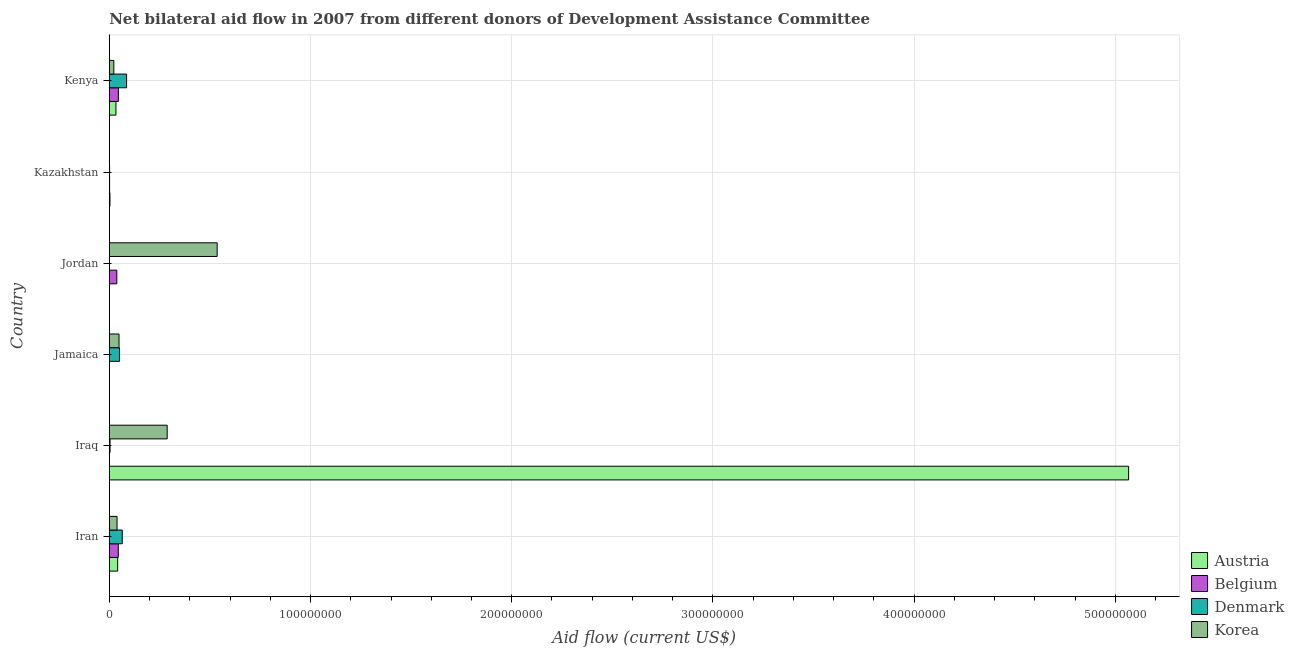How many groups of bars are there?
Ensure brevity in your answer.  6. Are the number of bars per tick equal to the number of legend labels?
Keep it short and to the point. No. Are the number of bars on each tick of the Y-axis equal?
Your response must be concise. No. What is the label of the 4th group of bars from the top?
Offer a very short reply. Jamaica. In how many cases, is the number of bars for a given country not equal to the number of legend labels?
Keep it short and to the point. 2. What is the amount of aid given by austria in Iran?
Your response must be concise. 4.17e+06. Across all countries, what is the maximum amount of aid given by denmark?
Your answer should be compact. 8.61e+06. Across all countries, what is the minimum amount of aid given by denmark?
Keep it short and to the point. 0. In which country was the amount of aid given by belgium maximum?
Give a very brief answer. Kenya. What is the total amount of aid given by denmark in the graph?
Provide a succinct answer. 2.07e+07. What is the difference between the amount of aid given by belgium in Jamaica and that in Kazakhstan?
Your response must be concise. -1.00e+05. What is the difference between the amount of aid given by denmark in Iran and the amount of aid given by korea in Jordan?
Give a very brief answer. -4.72e+07. What is the average amount of aid given by korea per country?
Your answer should be very brief. 1.56e+07. What is the difference between the amount of aid given by austria and amount of aid given by denmark in Kenya?
Make the answer very short. -5.30e+06. What is the ratio of the amount of aid given by korea in Kazakhstan to that in Kenya?
Offer a terse response. 0.04. What is the difference between the highest and the second highest amount of aid given by denmark?
Provide a succinct answer. 2.16e+06. What is the difference between the highest and the lowest amount of aid given by korea?
Provide a short and direct response. 5.35e+07. Is it the case that in every country, the sum of the amount of aid given by korea and amount of aid given by denmark is greater than the sum of amount of aid given by austria and amount of aid given by belgium?
Offer a very short reply. No. How many bars are there?
Your response must be concise. 22. Are all the bars in the graph horizontal?
Offer a terse response. Yes. What is the difference between two consecutive major ticks on the X-axis?
Your answer should be compact. 1.00e+08. Are the values on the major ticks of X-axis written in scientific E-notation?
Your response must be concise. No. Does the graph contain any zero values?
Make the answer very short. Yes. Does the graph contain grids?
Provide a short and direct response. Yes. How many legend labels are there?
Your answer should be very brief. 4. What is the title of the graph?
Give a very brief answer. Net bilateral aid flow in 2007 from different donors of Development Assistance Committee. What is the label or title of the Y-axis?
Give a very brief answer. Country. What is the Aid flow (current US$) of Austria in Iran?
Keep it short and to the point. 4.17e+06. What is the Aid flow (current US$) of Belgium in Iran?
Keep it short and to the point. 4.48e+06. What is the Aid flow (current US$) of Denmark in Iran?
Keep it short and to the point. 6.45e+06. What is the Aid flow (current US$) of Korea in Iran?
Your response must be concise. 3.86e+06. What is the Aid flow (current US$) in Austria in Iraq?
Give a very brief answer. 5.07e+08. What is the Aid flow (current US$) of Belgium in Iraq?
Your answer should be compact. 0. What is the Aid flow (current US$) in Korea in Iraq?
Ensure brevity in your answer.  2.88e+07. What is the Aid flow (current US$) of Austria in Jamaica?
Give a very brief answer. 10000. What is the Aid flow (current US$) in Denmark in Jamaica?
Your answer should be very brief. 5.06e+06. What is the Aid flow (current US$) in Korea in Jamaica?
Ensure brevity in your answer.  4.85e+06. What is the Aid flow (current US$) of Belgium in Jordan?
Ensure brevity in your answer.  3.74e+06. What is the Aid flow (current US$) of Korea in Jordan?
Make the answer very short. 5.36e+07. What is the Aid flow (current US$) of Austria in Kazakhstan?
Your response must be concise. 3.40e+05. What is the Aid flow (current US$) of Denmark in Kazakhstan?
Provide a short and direct response. 1.60e+05. What is the Aid flow (current US$) of Austria in Kenya?
Ensure brevity in your answer.  3.31e+06. What is the Aid flow (current US$) in Belgium in Kenya?
Give a very brief answer. 4.52e+06. What is the Aid flow (current US$) of Denmark in Kenya?
Ensure brevity in your answer.  8.61e+06. What is the Aid flow (current US$) in Korea in Kenya?
Your answer should be compact. 2.26e+06. Across all countries, what is the maximum Aid flow (current US$) in Austria?
Provide a succinct answer. 5.07e+08. Across all countries, what is the maximum Aid flow (current US$) of Belgium?
Offer a terse response. 4.52e+06. Across all countries, what is the maximum Aid flow (current US$) in Denmark?
Ensure brevity in your answer.  8.61e+06. Across all countries, what is the maximum Aid flow (current US$) of Korea?
Provide a short and direct response. 5.36e+07. Across all countries, what is the minimum Aid flow (current US$) of Korea?
Give a very brief answer. 1.00e+05. What is the total Aid flow (current US$) in Austria in the graph?
Make the answer very short. 5.14e+08. What is the total Aid flow (current US$) in Belgium in the graph?
Give a very brief answer. 1.30e+07. What is the total Aid flow (current US$) of Denmark in the graph?
Provide a short and direct response. 2.07e+07. What is the total Aid flow (current US$) in Korea in the graph?
Give a very brief answer. 9.35e+07. What is the difference between the Aid flow (current US$) in Austria in Iran and that in Iraq?
Provide a short and direct response. -5.02e+08. What is the difference between the Aid flow (current US$) in Denmark in Iran and that in Iraq?
Ensure brevity in your answer.  6.06e+06. What is the difference between the Aid flow (current US$) of Korea in Iran and that in Iraq?
Make the answer very short. -2.49e+07. What is the difference between the Aid flow (current US$) in Austria in Iran and that in Jamaica?
Offer a very short reply. 4.16e+06. What is the difference between the Aid flow (current US$) in Belgium in Iran and that in Jamaica?
Your answer should be very brief. 4.42e+06. What is the difference between the Aid flow (current US$) of Denmark in Iran and that in Jamaica?
Provide a short and direct response. 1.39e+06. What is the difference between the Aid flow (current US$) of Korea in Iran and that in Jamaica?
Your answer should be very brief. -9.90e+05. What is the difference between the Aid flow (current US$) of Austria in Iran and that in Jordan?
Your response must be concise. 4.07e+06. What is the difference between the Aid flow (current US$) in Belgium in Iran and that in Jordan?
Your response must be concise. 7.40e+05. What is the difference between the Aid flow (current US$) in Korea in Iran and that in Jordan?
Provide a succinct answer. -4.98e+07. What is the difference between the Aid flow (current US$) in Austria in Iran and that in Kazakhstan?
Keep it short and to the point. 3.83e+06. What is the difference between the Aid flow (current US$) of Belgium in Iran and that in Kazakhstan?
Ensure brevity in your answer.  4.32e+06. What is the difference between the Aid flow (current US$) in Denmark in Iran and that in Kazakhstan?
Give a very brief answer. 6.29e+06. What is the difference between the Aid flow (current US$) of Korea in Iran and that in Kazakhstan?
Offer a terse response. 3.76e+06. What is the difference between the Aid flow (current US$) of Austria in Iran and that in Kenya?
Your response must be concise. 8.60e+05. What is the difference between the Aid flow (current US$) of Denmark in Iran and that in Kenya?
Give a very brief answer. -2.16e+06. What is the difference between the Aid flow (current US$) of Korea in Iran and that in Kenya?
Your answer should be compact. 1.60e+06. What is the difference between the Aid flow (current US$) in Austria in Iraq and that in Jamaica?
Keep it short and to the point. 5.07e+08. What is the difference between the Aid flow (current US$) in Denmark in Iraq and that in Jamaica?
Ensure brevity in your answer.  -4.67e+06. What is the difference between the Aid flow (current US$) of Korea in Iraq and that in Jamaica?
Keep it short and to the point. 2.39e+07. What is the difference between the Aid flow (current US$) in Austria in Iraq and that in Jordan?
Provide a short and direct response. 5.06e+08. What is the difference between the Aid flow (current US$) in Korea in Iraq and that in Jordan?
Your response must be concise. -2.48e+07. What is the difference between the Aid flow (current US$) of Austria in Iraq and that in Kazakhstan?
Your answer should be very brief. 5.06e+08. What is the difference between the Aid flow (current US$) of Denmark in Iraq and that in Kazakhstan?
Ensure brevity in your answer.  2.30e+05. What is the difference between the Aid flow (current US$) of Korea in Iraq and that in Kazakhstan?
Offer a very short reply. 2.87e+07. What is the difference between the Aid flow (current US$) of Austria in Iraq and that in Kenya?
Offer a terse response. 5.03e+08. What is the difference between the Aid flow (current US$) in Denmark in Iraq and that in Kenya?
Ensure brevity in your answer.  -8.22e+06. What is the difference between the Aid flow (current US$) in Korea in Iraq and that in Kenya?
Provide a succinct answer. 2.65e+07. What is the difference between the Aid flow (current US$) in Austria in Jamaica and that in Jordan?
Your answer should be compact. -9.00e+04. What is the difference between the Aid flow (current US$) in Belgium in Jamaica and that in Jordan?
Keep it short and to the point. -3.68e+06. What is the difference between the Aid flow (current US$) of Korea in Jamaica and that in Jordan?
Offer a very short reply. -4.88e+07. What is the difference between the Aid flow (current US$) in Austria in Jamaica and that in Kazakhstan?
Offer a very short reply. -3.30e+05. What is the difference between the Aid flow (current US$) of Denmark in Jamaica and that in Kazakhstan?
Give a very brief answer. 4.90e+06. What is the difference between the Aid flow (current US$) of Korea in Jamaica and that in Kazakhstan?
Give a very brief answer. 4.75e+06. What is the difference between the Aid flow (current US$) in Austria in Jamaica and that in Kenya?
Offer a very short reply. -3.30e+06. What is the difference between the Aid flow (current US$) in Belgium in Jamaica and that in Kenya?
Offer a terse response. -4.46e+06. What is the difference between the Aid flow (current US$) of Denmark in Jamaica and that in Kenya?
Your response must be concise. -3.55e+06. What is the difference between the Aid flow (current US$) of Korea in Jamaica and that in Kenya?
Your answer should be compact. 2.59e+06. What is the difference between the Aid flow (current US$) in Belgium in Jordan and that in Kazakhstan?
Provide a succinct answer. 3.58e+06. What is the difference between the Aid flow (current US$) in Korea in Jordan and that in Kazakhstan?
Your answer should be compact. 5.35e+07. What is the difference between the Aid flow (current US$) in Austria in Jordan and that in Kenya?
Offer a very short reply. -3.21e+06. What is the difference between the Aid flow (current US$) of Belgium in Jordan and that in Kenya?
Your answer should be very brief. -7.80e+05. What is the difference between the Aid flow (current US$) of Korea in Jordan and that in Kenya?
Your answer should be compact. 5.14e+07. What is the difference between the Aid flow (current US$) of Austria in Kazakhstan and that in Kenya?
Provide a short and direct response. -2.97e+06. What is the difference between the Aid flow (current US$) of Belgium in Kazakhstan and that in Kenya?
Provide a short and direct response. -4.36e+06. What is the difference between the Aid flow (current US$) of Denmark in Kazakhstan and that in Kenya?
Your answer should be very brief. -8.45e+06. What is the difference between the Aid flow (current US$) in Korea in Kazakhstan and that in Kenya?
Keep it short and to the point. -2.16e+06. What is the difference between the Aid flow (current US$) of Austria in Iran and the Aid flow (current US$) of Denmark in Iraq?
Keep it short and to the point. 3.78e+06. What is the difference between the Aid flow (current US$) in Austria in Iran and the Aid flow (current US$) in Korea in Iraq?
Provide a short and direct response. -2.46e+07. What is the difference between the Aid flow (current US$) in Belgium in Iran and the Aid flow (current US$) in Denmark in Iraq?
Your answer should be very brief. 4.09e+06. What is the difference between the Aid flow (current US$) of Belgium in Iran and the Aid flow (current US$) of Korea in Iraq?
Offer a very short reply. -2.43e+07. What is the difference between the Aid flow (current US$) in Denmark in Iran and the Aid flow (current US$) in Korea in Iraq?
Provide a short and direct response. -2.23e+07. What is the difference between the Aid flow (current US$) in Austria in Iran and the Aid flow (current US$) in Belgium in Jamaica?
Offer a terse response. 4.11e+06. What is the difference between the Aid flow (current US$) of Austria in Iran and the Aid flow (current US$) of Denmark in Jamaica?
Provide a short and direct response. -8.90e+05. What is the difference between the Aid flow (current US$) of Austria in Iran and the Aid flow (current US$) of Korea in Jamaica?
Keep it short and to the point. -6.80e+05. What is the difference between the Aid flow (current US$) in Belgium in Iran and the Aid flow (current US$) in Denmark in Jamaica?
Keep it short and to the point. -5.80e+05. What is the difference between the Aid flow (current US$) in Belgium in Iran and the Aid flow (current US$) in Korea in Jamaica?
Offer a terse response. -3.70e+05. What is the difference between the Aid flow (current US$) of Denmark in Iran and the Aid flow (current US$) of Korea in Jamaica?
Keep it short and to the point. 1.60e+06. What is the difference between the Aid flow (current US$) in Austria in Iran and the Aid flow (current US$) in Belgium in Jordan?
Give a very brief answer. 4.30e+05. What is the difference between the Aid flow (current US$) in Austria in Iran and the Aid flow (current US$) in Korea in Jordan?
Offer a terse response. -4.94e+07. What is the difference between the Aid flow (current US$) in Belgium in Iran and the Aid flow (current US$) in Korea in Jordan?
Your answer should be very brief. -4.91e+07. What is the difference between the Aid flow (current US$) of Denmark in Iran and the Aid flow (current US$) of Korea in Jordan?
Give a very brief answer. -4.72e+07. What is the difference between the Aid flow (current US$) in Austria in Iran and the Aid flow (current US$) in Belgium in Kazakhstan?
Give a very brief answer. 4.01e+06. What is the difference between the Aid flow (current US$) of Austria in Iran and the Aid flow (current US$) of Denmark in Kazakhstan?
Your answer should be very brief. 4.01e+06. What is the difference between the Aid flow (current US$) of Austria in Iran and the Aid flow (current US$) of Korea in Kazakhstan?
Your answer should be compact. 4.07e+06. What is the difference between the Aid flow (current US$) of Belgium in Iran and the Aid flow (current US$) of Denmark in Kazakhstan?
Provide a short and direct response. 4.32e+06. What is the difference between the Aid flow (current US$) in Belgium in Iran and the Aid flow (current US$) in Korea in Kazakhstan?
Your answer should be compact. 4.38e+06. What is the difference between the Aid flow (current US$) of Denmark in Iran and the Aid flow (current US$) of Korea in Kazakhstan?
Give a very brief answer. 6.35e+06. What is the difference between the Aid flow (current US$) of Austria in Iran and the Aid flow (current US$) of Belgium in Kenya?
Ensure brevity in your answer.  -3.50e+05. What is the difference between the Aid flow (current US$) in Austria in Iran and the Aid flow (current US$) in Denmark in Kenya?
Offer a terse response. -4.44e+06. What is the difference between the Aid flow (current US$) of Austria in Iran and the Aid flow (current US$) of Korea in Kenya?
Ensure brevity in your answer.  1.91e+06. What is the difference between the Aid flow (current US$) of Belgium in Iran and the Aid flow (current US$) of Denmark in Kenya?
Your answer should be compact. -4.13e+06. What is the difference between the Aid flow (current US$) of Belgium in Iran and the Aid flow (current US$) of Korea in Kenya?
Your answer should be compact. 2.22e+06. What is the difference between the Aid flow (current US$) of Denmark in Iran and the Aid flow (current US$) of Korea in Kenya?
Provide a succinct answer. 4.19e+06. What is the difference between the Aid flow (current US$) in Austria in Iraq and the Aid flow (current US$) in Belgium in Jamaica?
Offer a very short reply. 5.06e+08. What is the difference between the Aid flow (current US$) in Austria in Iraq and the Aid flow (current US$) in Denmark in Jamaica?
Give a very brief answer. 5.01e+08. What is the difference between the Aid flow (current US$) in Austria in Iraq and the Aid flow (current US$) in Korea in Jamaica?
Offer a very short reply. 5.02e+08. What is the difference between the Aid flow (current US$) of Denmark in Iraq and the Aid flow (current US$) of Korea in Jamaica?
Your answer should be compact. -4.46e+06. What is the difference between the Aid flow (current US$) in Austria in Iraq and the Aid flow (current US$) in Belgium in Jordan?
Your response must be concise. 5.03e+08. What is the difference between the Aid flow (current US$) of Austria in Iraq and the Aid flow (current US$) of Korea in Jordan?
Ensure brevity in your answer.  4.53e+08. What is the difference between the Aid flow (current US$) of Denmark in Iraq and the Aid flow (current US$) of Korea in Jordan?
Your answer should be very brief. -5.32e+07. What is the difference between the Aid flow (current US$) of Austria in Iraq and the Aid flow (current US$) of Belgium in Kazakhstan?
Provide a succinct answer. 5.06e+08. What is the difference between the Aid flow (current US$) in Austria in Iraq and the Aid flow (current US$) in Denmark in Kazakhstan?
Your response must be concise. 5.06e+08. What is the difference between the Aid flow (current US$) of Austria in Iraq and the Aid flow (current US$) of Korea in Kazakhstan?
Provide a succinct answer. 5.06e+08. What is the difference between the Aid flow (current US$) in Denmark in Iraq and the Aid flow (current US$) in Korea in Kazakhstan?
Offer a very short reply. 2.90e+05. What is the difference between the Aid flow (current US$) in Austria in Iraq and the Aid flow (current US$) in Belgium in Kenya?
Your response must be concise. 5.02e+08. What is the difference between the Aid flow (current US$) of Austria in Iraq and the Aid flow (current US$) of Denmark in Kenya?
Provide a succinct answer. 4.98e+08. What is the difference between the Aid flow (current US$) of Austria in Iraq and the Aid flow (current US$) of Korea in Kenya?
Ensure brevity in your answer.  5.04e+08. What is the difference between the Aid flow (current US$) in Denmark in Iraq and the Aid flow (current US$) in Korea in Kenya?
Provide a short and direct response. -1.87e+06. What is the difference between the Aid flow (current US$) in Austria in Jamaica and the Aid flow (current US$) in Belgium in Jordan?
Give a very brief answer. -3.73e+06. What is the difference between the Aid flow (current US$) in Austria in Jamaica and the Aid flow (current US$) in Korea in Jordan?
Offer a very short reply. -5.36e+07. What is the difference between the Aid flow (current US$) of Belgium in Jamaica and the Aid flow (current US$) of Korea in Jordan?
Offer a very short reply. -5.36e+07. What is the difference between the Aid flow (current US$) of Denmark in Jamaica and the Aid flow (current US$) of Korea in Jordan?
Your response must be concise. -4.86e+07. What is the difference between the Aid flow (current US$) in Austria in Jamaica and the Aid flow (current US$) in Denmark in Kazakhstan?
Your answer should be very brief. -1.50e+05. What is the difference between the Aid flow (current US$) of Belgium in Jamaica and the Aid flow (current US$) of Denmark in Kazakhstan?
Make the answer very short. -1.00e+05. What is the difference between the Aid flow (current US$) in Belgium in Jamaica and the Aid flow (current US$) in Korea in Kazakhstan?
Your answer should be very brief. -4.00e+04. What is the difference between the Aid flow (current US$) of Denmark in Jamaica and the Aid flow (current US$) of Korea in Kazakhstan?
Your answer should be very brief. 4.96e+06. What is the difference between the Aid flow (current US$) of Austria in Jamaica and the Aid flow (current US$) of Belgium in Kenya?
Provide a short and direct response. -4.51e+06. What is the difference between the Aid flow (current US$) in Austria in Jamaica and the Aid flow (current US$) in Denmark in Kenya?
Offer a very short reply. -8.60e+06. What is the difference between the Aid flow (current US$) of Austria in Jamaica and the Aid flow (current US$) of Korea in Kenya?
Offer a very short reply. -2.25e+06. What is the difference between the Aid flow (current US$) of Belgium in Jamaica and the Aid flow (current US$) of Denmark in Kenya?
Offer a terse response. -8.55e+06. What is the difference between the Aid flow (current US$) of Belgium in Jamaica and the Aid flow (current US$) of Korea in Kenya?
Your answer should be compact. -2.20e+06. What is the difference between the Aid flow (current US$) of Denmark in Jamaica and the Aid flow (current US$) of Korea in Kenya?
Your response must be concise. 2.80e+06. What is the difference between the Aid flow (current US$) in Austria in Jordan and the Aid flow (current US$) in Belgium in Kazakhstan?
Offer a terse response. -6.00e+04. What is the difference between the Aid flow (current US$) of Austria in Jordan and the Aid flow (current US$) of Denmark in Kazakhstan?
Make the answer very short. -6.00e+04. What is the difference between the Aid flow (current US$) of Belgium in Jordan and the Aid flow (current US$) of Denmark in Kazakhstan?
Provide a short and direct response. 3.58e+06. What is the difference between the Aid flow (current US$) of Belgium in Jordan and the Aid flow (current US$) of Korea in Kazakhstan?
Your response must be concise. 3.64e+06. What is the difference between the Aid flow (current US$) of Austria in Jordan and the Aid flow (current US$) of Belgium in Kenya?
Offer a very short reply. -4.42e+06. What is the difference between the Aid flow (current US$) of Austria in Jordan and the Aid flow (current US$) of Denmark in Kenya?
Give a very brief answer. -8.51e+06. What is the difference between the Aid flow (current US$) in Austria in Jordan and the Aid flow (current US$) in Korea in Kenya?
Give a very brief answer. -2.16e+06. What is the difference between the Aid flow (current US$) of Belgium in Jordan and the Aid flow (current US$) of Denmark in Kenya?
Your answer should be very brief. -4.87e+06. What is the difference between the Aid flow (current US$) of Belgium in Jordan and the Aid flow (current US$) of Korea in Kenya?
Give a very brief answer. 1.48e+06. What is the difference between the Aid flow (current US$) of Austria in Kazakhstan and the Aid flow (current US$) of Belgium in Kenya?
Your response must be concise. -4.18e+06. What is the difference between the Aid flow (current US$) in Austria in Kazakhstan and the Aid flow (current US$) in Denmark in Kenya?
Make the answer very short. -8.27e+06. What is the difference between the Aid flow (current US$) in Austria in Kazakhstan and the Aid flow (current US$) in Korea in Kenya?
Give a very brief answer. -1.92e+06. What is the difference between the Aid flow (current US$) in Belgium in Kazakhstan and the Aid flow (current US$) in Denmark in Kenya?
Provide a succinct answer. -8.45e+06. What is the difference between the Aid flow (current US$) in Belgium in Kazakhstan and the Aid flow (current US$) in Korea in Kenya?
Make the answer very short. -2.10e+06. What is the difference between the Aid flow (current US$) of Denmark in Kazakhstan and the Aid flow (current US$) of Korea in Kenya?
Provide a short and direct response. -2.10e+06. What is the average Aid flow (current US$) in Austria per country?
Keep it short and to the point. 8.57e+07. What is the average Aid flow (current US$) of Belgium per country?
Give a very brief answer. 2.16e+06. What is the average Aid flow (current US$) in Denmark per country?
Your answer should be very brief. 3.44e+06. What is the average Aid flow (current US$) in Korea per country?
Keep it short and to the point. 1.56e+07. What is the difference between the Aid flow (current US$) in Austria and Aid flow (current US$) in Belgium in Iran?
Provide a short and direct response. -3.10e+05. What is the difference between the Aid flow (current US$) in Austria and Aid flow (current US$) in Denmark in Iran?
Ensure brevity in your answer.  -2.28e+06. What is the difference between the Aid flow (current US$) of Belgium and Aid flow (current US$) of Denmark in Iran?
Provide a short and direct response. -1.97e+06. What is the difference between the Aid flow (current US$) in Belgium and Aid flow (current US$) in Korea in Iran?
Provide a succinct answer. 6.20e+05. What is the difference between the Aid flow (current US$) of Denmark and Aid flow (current US$) of Korea in Iran?
Provide a short and direct response. 2.59e+06. What is the difference between the Aid flow (current US$) in Austria and Aid flow (current US$) in Denmark in Iraq?
Provide a succinct answer. 5.06e+08. What is the difference between the Aid flow (current US$) of Austria and Aid flow (current US$) of Korea in Iraq?
Give a very brief answer. 4.78e+08. What is the difference between the Aid flow (current US$) of Denmark and Aid flow (current US$) of Korea in Iraq?
Your answer should be very brief. -2.84e+07. What is the difference between the Aid flow (current US$) of Austria and Aid flow (current US$) of Belgium in Jamaica?
Offer a terse response. -5.00e+04. What is the difference between the Aid flow (current US$) in Austria and Aid flow (current US$) in Denmark in Jamaica?
Your answer should be compact. -5.05e+06. What is the difference between the Aid flow (current US$) of Austria and Aid flow (current US$) of Korea in Jamaica?
Offer a very short reply. -4.84e+06. What is the difference between the Aid flow (current US$) of Belgium and Aid flow (current US$) of Denmark in Jamaica?
Your response must be concise. -5.00e+06. What is the difference between the Aid flow (current US$) of Belgium and Aid flow (current US$) of Korea in Jamaica?
Your answer should be compact. -4.79e+06. What is the difference between the Aid flow (current US$) in Austria and Aid flow (current US$) in Belgium in Jordan?
Your answer should be compact. -3.64e+06. What is the difference between the Aid flow (current US$) in Austria and Aid flow (current US$) in Korea in Jordan?
Offer a very short reply. -5.35e+07. What is the difference between the Aid flow (current US$) of Belgium and Aid flow (current US$) of Korea in Jordan?
Give a very brief answer. -4.99e+07. What is the difference between the Aid flow (current US$) of Denmark and Aid flow (current US$) of Korea in Kazakhstan?
Make the answer very short. 6.00e+04. What is the difference between the Aid flow (current US$) in Austria and Aid flow (current US$) in Belgium in Kenya?
Give a very brief answer. -1.21e+06. What is the difference between the Aid flow (current US$) in Austria and Aid flow (current US$) in Denmark in Kenya?
Ensure brevity in your answer.  -5.30e+06. What is the difference between the Aid flow (current US$) in Austria and Aid flow (current US$) in Korea in Kenya?
Your response must be concise. 1.05e+06. What is the difference between the Aid flow (current US$) of Belgium and Aid flow (current US$) of Denmark in Kenya?
Offer a terse response. -4.09e+06. What is the difference between the Aid flow (current US$) in Belgium and Aid flow (current US$) in Korea in Kenya?
Your answer should be very brief. 2.26e+06. What is the difference between the Aid flow (current US$) in Denmark and Aid flow (current US$) in Korea in Kenya?
Your answer should be compact. 6.35e+06. What is the ratio of the Aid flow (current US$) of Austria in Iran to that in Iraq?
Give a very brief answer. 0.01. What is the ratio of the Aid flow (current US$) in Denmark in Iran to that in Iraq?
Your answer should be very brief. 16.54. What is the ratio of the Aid flow (current US$) in Korea in Iran to that in Iraq?
Keep it short and to the point. 0.13. What is the ratio of the Aid flow (current US$) of Austria in Iran to that in Jamaica?
Your answer should be compact. 417. What is the ratio of the Aid flow (current US$) in Belgium in Iran to that in Jamaica?
Ensure brevity in your answer.  74.67. What is the ratio of the Aid flow (current US$) in Denmark in Iran to that in Jamaica?
Keep it short and to the point. 1.27. What is the ratio of the Aid flow (current US$) of Korea in Iran to that in Jamaica?
Offer a very short reply. 0.8. What is the ratio of the Aid flow (current US$) of Austria in Iran to that in Jordan?
Your response must be concise. 41.7. What is the ratio of the Aid flow (current US$) of Belgium in Iran to that in Jordan?
Offer a very short reply. 1.2. What is the ratio of the Aid flow (current US$) of Korea in Iran to that in Jordan?
Give a very brief answer. 0.07. What is the ratio of the Aid flow (current US$) in Austria in Iran to that in Kazakhstan?
Your answer should be compact. 12.26. What is the ratio of the Aid flow (current US$) of Denmark in Iran to that in Kazakhstan?
Ensure brevity in your answer.  40.31. What is the ratio of the Aid flow (current US$) in Korea in Iran to that in Kazakhstan?
Make the answer very short. 38.6. What is the ratio of the Aid flow (current US$) of Austria in Iran to that in Kenya?
Provide a short and direct response. 1.26. What is the ratio of the Aid flow (current US$) of Belgium in Iran to that in Kenya?
Make the answer very short. 0.99. What is the ratio of the Aid flow (current US$) of Denmark in Iran to that in Kenya?
Keep it short and to the point. 0.75. What is the ratio of the Aid flow (current US$) in Korea in Iran to that in Kenya?
Ensure brevity in your answer.  1.71. What is the ratio of the Aid flow (current US$) in Austria in Iraq to that in Jamaica?
Ensure brevity in your answer.  5.07e+04. What is the ratio of the Aid flow (current US$) in Denmark in Iraq to that in Jamaica?
Ensure brevity in your answer.  0.08. What is the ratio of the Aid flow (current US$) of Korea in Iraq to that in Jamaica?
Ensure brevity in your answer.  5.93. What is the ratio of the Aid flow (current US$) of Austria in Iraq to that in Jordan?
Offer a very short reply. 5065.4. What is the ratio of the Aid flow (current US$) in Korea in Iraq to that in Jordan?
Make the answer very short. 0.54. What is the ratio of the Aid flow (current US$) of Austria in Iraq to that in Kazakhstan?
Ensure brevity in your answer.  1489.82. What is the ratio of the Aid flow (current US$) of Denmark in Iraq to that in Kazakhstan?
Your answer should be compact. 2.44. What is the ratio of the Aid flow (current US$) of Korea in Iraq to that in Kazakhstan?
Provide a succinct answer. 287.8. What is the ratio of the Aid flow (current US$) of Austria in Iraq to that in Kenya?
Your answer should be compact. 153.03. What is the ratio of the Aid flow (current US$) in Denmark in Iraq to that in Kenya?
Ensure brevity in your answer.  0.05. What is the ratio of the Aid flow (current US$) of Korea in Iraq to that in Kenya?
Your answer should be very brief. 12.73. What is the ratio of the Aid flow (current US$) of Austria in Jamaica to that in Jordan?
Your response must be concise. 0.1. What is the ratio of the Aid flow (current US$) of Belgium in Jamaica to that in Jordan?
Ensure brevity in your answer.  0.02. What is the ratio of the Aid flow (current US$) of Korea in Jamaica to that in Jordan?
Give a very brief answer. 0.09. What is the ratio of the Aid flow (current US$) of Austria in Jamaica to that in Kazakhstan?
Your response must be concise. 0.03. What is the ratio of the Aid flow (current US$) in Belgium in Jamaica to that in Kazakhstan?
Give a very brief answer. 0.38. What is the ratio of the Aid flow (current US$) of Denmark in Jamaica to that in Kazakhstan?
Give a very brief answer. 31.62. What is the ratio of the Aid flow (current US$) in Korea in Jamaica to that in Kazakhstan?
Offer a very short reply. 48.5. What is the ratio of the Aid flow (current US$) of Austria in Jamaica to that in Kenya?
Provide a succinct answer. 0. What is the ratio of the Aid flow (current US$) in Belgium in Jamaica to that in Kenya?
Your answer should be compact. 0.01. What is the ratio of the Aid flow (current US$) of Denmark in Jamaica to that in Kenya?
Offer a very short reply. 0.59. What is the ratio of the Aid flow (current US$) of Korea in Jamaica to that in Kenya?
Give a very brief answer. 2.15. What is the ratio of the Aid flow (current US$) in Austria in Jordan to that in Kazakhstan?
Provide a succinct answer. 0.29. What is the ratio of the Aid flow (current US$) in Belgium in Jordan to that in Kazakhstan?
Provide a short and direct response. 23.38. What is the ratio of the Aid flow (current US$) of Korea in Jordan to that in Kazakhstan?
Your answer should be very brief. 536.2. What is the ratio of the Aid flow (current US$) of Austria in Jordan to that in Kenya?
Your response must be concise. 0.03. What is the ratio of the Aid flow (current US$) in Belgium in Jordan to that in Kenya?
Your answer should be compact. 0.83. What is the ratio of the Aid flow (current US$) in Korea in Jordan to that in Kenya?
Give a very brief answer. 23.73. What is the ratio of the Aid flow (current US$) in Austria in Kazakhstan to that in Kenya?
Offer a terse response. 0.1. What is the ratio of the Aid flow (current US$) in Belgium in Kazakhstan to that in Kenya?
Your response must be concise. 0.04. What is the ratio of the Aid flow (current US$) in Denmark in Kazakhstan to that in Kenya?
Your response must be concise. 0.02. What is the ratio of the Aid flow (current US$) of Korea in Kazakhstan to that in Kenya?
Keep it short and to the point. 0.04. What is the difference between the highest and the second highest Aid flow (current US$) in Austria?
Your answer should be very brief. 5.02e+08. What is the difference between the highest and the second highest Aid flow (current US$) of Denmark?
Offer a terse response. 2.16e+06. What is the difference between the highest and the second highest Aid flow (current US$) of Korea?
Keep it short and to the point. 2.48e+07. What is the difference between the highest and the lowest Aid flow (current US$) of Austria?
Make the answer very short. 5.07e+08. What is the difference between the highest and the lowest Aid flow (current US$) of Belgium?
Your answer should be very brief. 4.52e+06. What is the difference between the highest and the lowest Aid flow (current US$) of Denmark?
Your answer should be very brief. 8.61e+06. What is the difference between the highest and the lowest Aid flow (current US$) of Korea?
Your answer should be compact. 5.35e+07. 